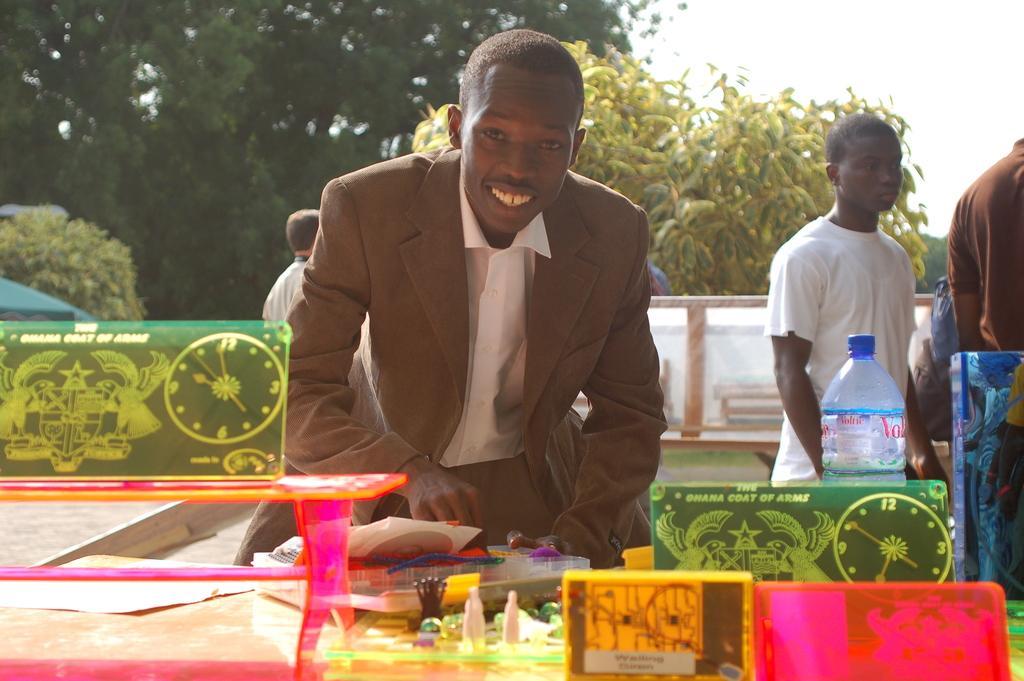In one or two sentences, can you explain what this image depicts? Far there are number of trees. Front this person wore suit and smiles. On this table there is a bottle and things. Far these persons are standing. 